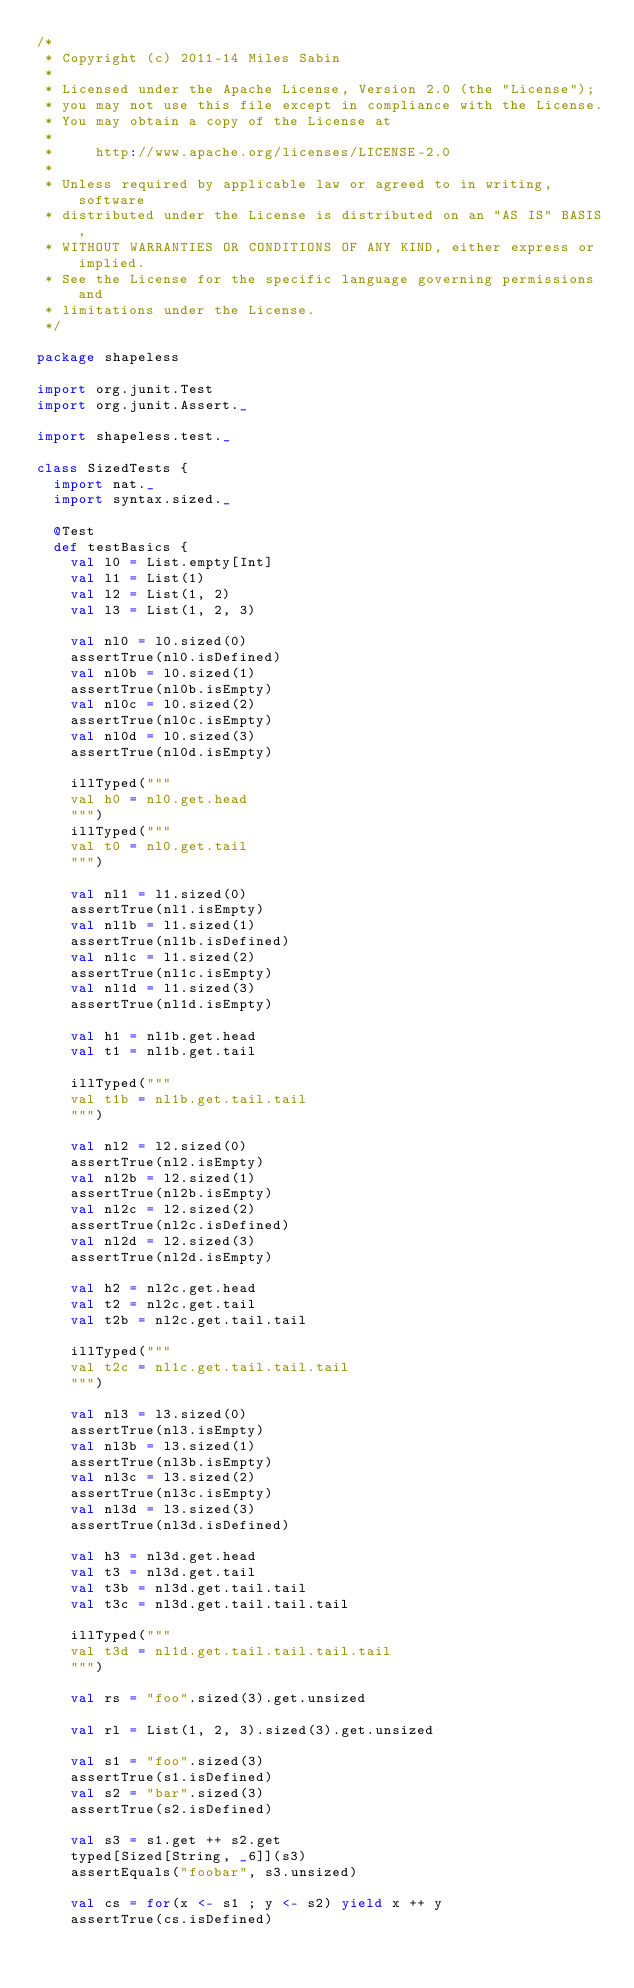Convert code to text. <code><loc_0><loc_0><loc_500><loc_500><_Scala_>/*
 * Copyright (c) 2011-14 Miles Sabin 
 *
 * Licensed under the Apache License, Version 2.0 (the "License");
 * you may not use this file except in compliance with the License.
 * You may obtain a copy of the License at
 *
 *     http://www.apache.org/licenses/LICENSE-2.0
 *
 * Unless required by applicable law or agreed to in writing, software
 * distributed under the License is distributed on an "AS IS" BASIS,
 * WITHOUT WARRANTIES OR CONDITIONS OF ANY KIND, either express or implied.
 * See the License for the specific language governing permissions and
 * limitations under the License.
 */

package shapeless

import org.junit.Test
import org.junit.Assert._

import shapeless.test._

class SizedTests {
  import nat._
  import syntax.sized._
  
  @Test
  def testBasics {
    val l0 = List.empty[Int]
    val l1 = List(1)
    val l2 = List(1, 2)
    val l3 = List(1, 2, 3)
    
    val nl0 = l0.sized(0)
    assertTrue(nl0.isDefined)
    val nl0b = l0.sized(1)
    assertTrue(nl0b.isEmpty)
    val nl0c = l0.sized(2)
    assertTrue(nl0c.isEmpty)
    val nl0d = l0.sized(3)
    assertTrue(nl0d.isEmpty)
    
    illTyped("""
    val h0 = nl0.get.head
    """)
    illTyped("""
    val t0 = nl0.get.tail
    """)
    
    val nl1 = l1.sized(0)
    assertTrue(nl1.isEmpty)
    val nl1b = l1.sized(1)
    assertTrue(nl1b.isDefined)
    val nl1c = l1.sized(2)
    assertTrue(nl1c.isEmpty)
    val nl1d = l1.sized(3)
    assertTrue(nl1d.isEmpty)

    val h1 = nl1b.get.head
    val t1 = nl1b.get.tail

    illTyped("""
    val t1b = nl1b.get.tail.tail
    """)

    val nl2 = l2.sized(0)
    assertTrue(nl2.isEmpty)
    val nl2b = l2.sized(1)
    assertTrue(nl2b.isEmpty)
    val nl2c = l2.sized(2)
    assertTrue(nl2c.isDefined)
    val nl2d = l2.sized(3)
    assertTrue(nl2d.isEmpty)
    
    val h2 = nl2c.get.head
    val t2 = nl2c.get.tail
    val t2b = nl2c.get.tail.tail

    illTyped("""
    val t2c = nl1c.get.tail.tail.tail
    """)

    val nl3 = l3.sized(0)
    assertTrue(nl3.isEmpty)
    val nl3b = l3.sized(1)
    assertTrue(nl3b.isEmpty)
    val nl3c = l3.sized(2)
    assertTrue(nl3c.isEmpty)
    val nl3d = l3.sized(3)
    assertTrue(nl3d.isDefined)

    val h3 = nl3d.get.head
    val t3 = nl3d.get.tail
    val t3b = nl3d.get.tail.tail
    val t3c = nl3d.get.tail.tail.tail

    illTyped("""
    val t3d = nl1d.get.tail.tail.tail.tail
    """)
    
    val rs = "foo".sized(3).get.unsized
    
    val rl = List(1, 2, 3).sized(3).get.unsized
    
    val s1 = "foo".sized(3)
    assertTrue(s1.isDefined)
    val s2 = "bar".sized(3)
    assertTrue(s2.isDefined)

    val s3 = s1.get ++ s2.get
    typed[Sized[String, _6]](s3)
    assertEquals("foobar", s3.unsized)
    
    val cs = for(x <- s1 ; y <- s2) yield x ++ y
    assertTrue(cs.isDefined)</code> 